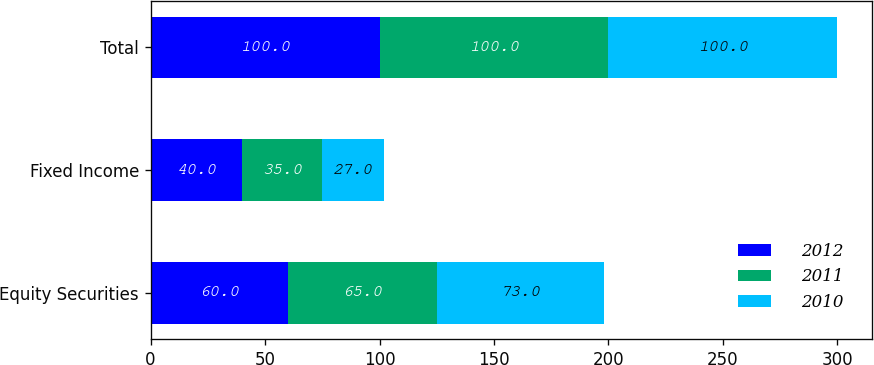<chart> <loc_0><loc_0><loc_500><loc_500><stacked_bar_chart><ecel><fcel>Equity Securities<fcel>Fixed Income<fcel>Total<nl><fcel>2012<fcel>60<fcel>40<fcel>100<nl><fcel>2011<fcel>65<fcel>35<fcel>100<nl><fcel>2010<fcel>73<fcel>27<fcel>100<nl></chart> 